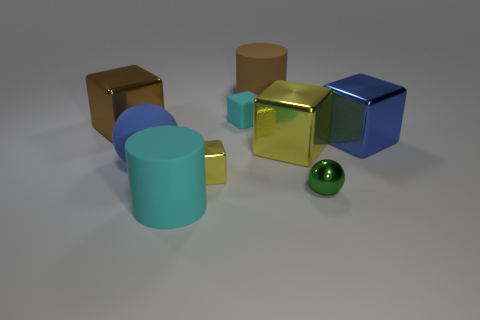There is a block that is to the left of the big cyan rubber object; are there any yellow blocks that are on the left side of it?
Keep it short and to the point. No. There is a shiny thing that is behind the blue shiny cube; does it have the same color as the big cylinder behind the large brown block?
Your response must be concise. Yes. There is a big blue block; what number of blue things are to the left of it?
Ensure brevity in your answer.  1. What number of big cubes are the same color as the rubber ball?
Provide a short and direct response. 1. Are the thing in front of the tiny green metal thing and the large yellow object made of the same material?
Keep it short and to the point. No. What number of big objects are the same material as the tiny yellow thing?
Ensure brevity in your answer.  3. Is the number of cyan objects that are in front of the big blue block greater than the number of yellow matte blocks?
Your response must be concise. Yes. What is the size of the thing that is the same color as the large rubber ball?
Your answer should be very brief. Large. Is there another blue thing of the same shape as the blue matte thing?
Provide a succinct answer. No. What number of things are either large rubber balls or small green matte objects?
Keep it short and to the point. 1. 